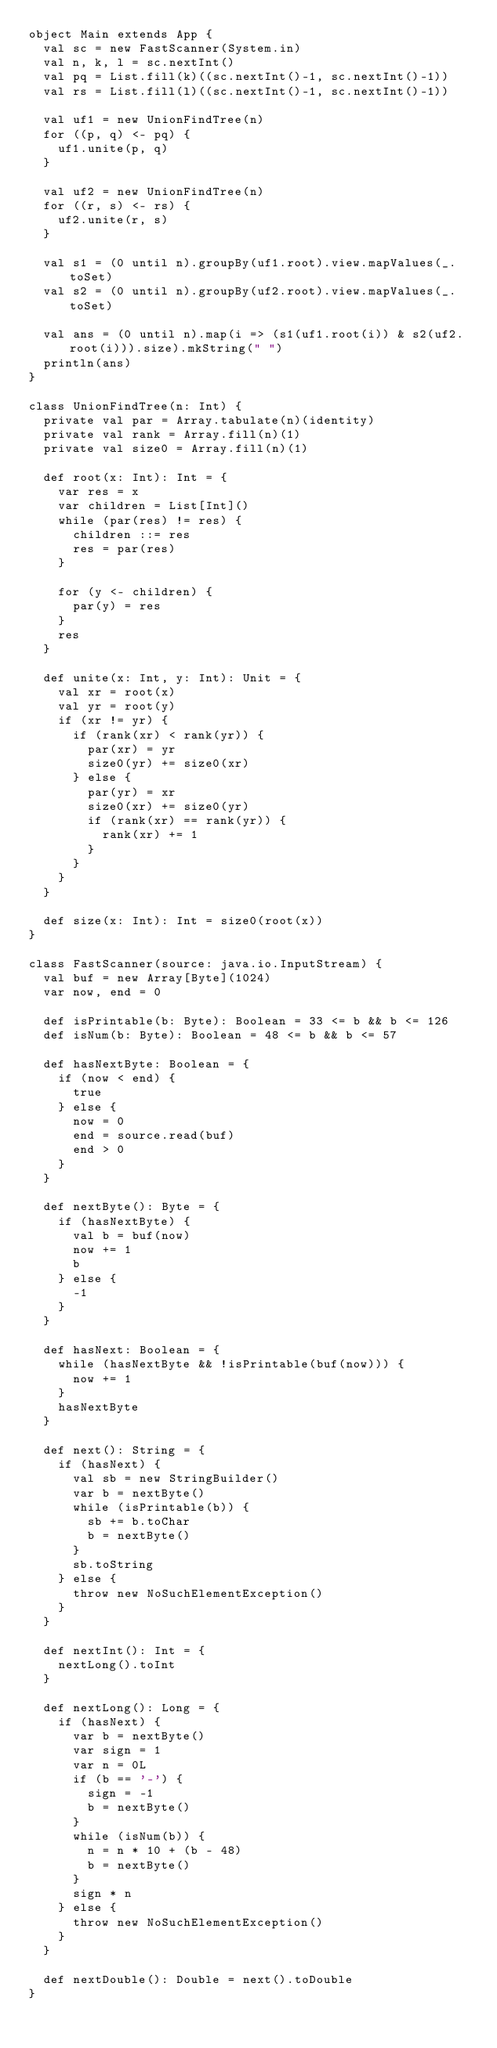Convert code to text. <code><loc_0><loc_0><loc_500><loc_500><_Scala_>object Main extends App {
  val sc = new FastScanner(System.in)
  val n, k, l = sc.nextInt()
  val pq = List.fill(k)((sc.nextInt()-1, sc.nextInt()-1))
  val rs = List.fill(l)((sc.nextInt()-1, sc.nextInt()-1))

  val uf1 = new UnionFindTree(n)
  for ((p, q) <- pq) {
    uf1.unite(p, q)
  }

  val uf2 = new UnionFindTree(n)
  for ((r, s) <- rs) {
    uf2.unite(r, s)
  }

  val s1 = (0 until n).groupBy(uf1.root).view.mapValues(_.toSet)
  val s2 = (0 until n).groupBy(uf2.root).view.mapValues(_.toSet)

  val ans = (0 until n).map(i => (s1(uf1.root(i)) & s2(uf2.root(i))).size).mkString(" ")
  println(ans)
}

class UnionFindTree(n: Int) {
  private val par = Array.tabulate(n)(identity)
  private val rank = Array.fill(n)(1)
  private val size0 = Array.fill(n)(1)

  def root(x: Int): Int = {
    var res = x
    var children = List[Int]()
    while (par(res) != res) {
      children ::= res
      res = par(res)
    }

    for (y <- children) {
      par(y) = res
    }
    res
  }

  def unite(x: Int, y: Int): Unit = {
    val xr = root(x)
    val yr = root(y)
    if (xr != yr) {
      if (rank(xr) < rank(yr)) {
        par(xr) = yr
        size0(yr) += size0(xr)
      } else {
        par(yr) = xr
        size0(xr) += size0(yr)
        if (rank(xr) == rank(yr)) {
          rank(xr) += 1
        }
      }
    }
  }

  def size(x: Int): Int = size0(root(x))
}

class FastScanner(source: java.io.InputStream) {
  val buf = new Array[Byte](1024)
  var now, end = 0

  def isPrintable(b: Byte): Boolean = 33 <= b && b <= 126
  def isNum(b: Byte): Boolean = 48 <= b && b <= 57

  def hasNextByte: Boolean = {
    if (now < end) {
      true
    } else {
      now = 0
      end = source.read(buf)
      end > 0
    }
  }

  def nextByte(): Byte = {
    if (hasNextByte) {
      val b = buf(now)
      now += 1
      b
    } else {
      -1
    }
  }

  def hasNext: Boolean = {
    while (hasNextByte && !isPrintable(buf(now))) {
      now += 1
    }
    hasNextByte
  }

  def next(): String = {
    if (hasNext) {
      val sb = new StringBuilder()
      var b = nextByte()
      while (isPrintable(b)) {
        sb += b.toChar
        b = nextByte()
      }
      sb.toString
    } else {
      throw new NoSuchElementException()
    }
  }

  def nextInt(): Int = {
    nextLong().toInt
  }

  def nextLong(): Long = {
    if (hasNext) {
      var b = nextByte()
      var sign = 1
      var n = 0L
      if (b == '-') {
        sign = -1
        b = nextByte()
      }
      while (isNum(b)) {
        n = n * 10 + (b - 48)
        b = nextByte()
      }
      sign * n
    } else {
      throw new NoSuchElementException()
    }
  }

  def nextDouble(): Double = next().toDouble
}
</code> 